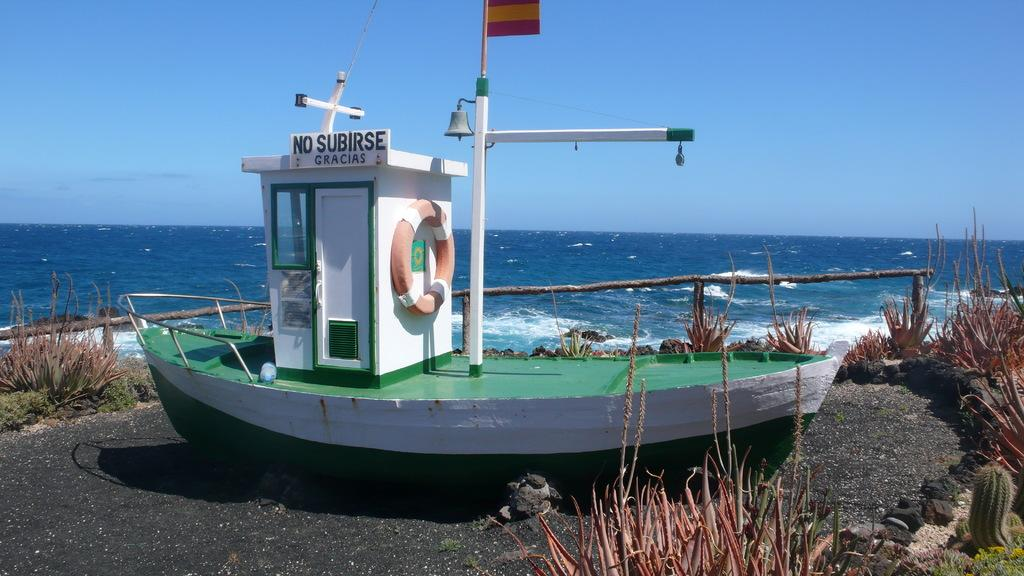What is the main subject in the foreground of the image? There is a boat in the foreground of the image. What is the current location of the boat? The boat is on the ground. What type of vegetation is present around the boat? There are plants around the boat. What can be seen behind the boat? There is a wooden railing behind the boat. What is visible in the background of the image? Water and the sky are visible in the background of the image. What type of amusement can be seen in the image? There is no amusement present in the image; it features a boat on the ground with plants, a wooden railing, and a background of water and sky. What type of agreement is being made between the boat and the plants in the image? There is no agreement being made between the boat and the plants in the image; they are simply objects in the scene. 